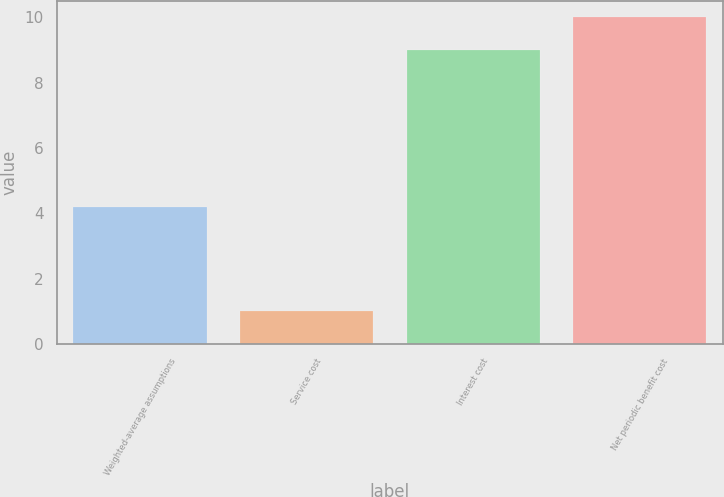Convert chart to OTSL. <chart><loc_0><loc_0><loc_500><loc_500><bar_chart><fcel>Weighted-average assumptions<fcel>Service cost<fcel>Interest cost<fcel>Net periodic benefit cost<nl><fcel>4.2<fcel>1<fcel>9<fcel>10<nl></chart> 